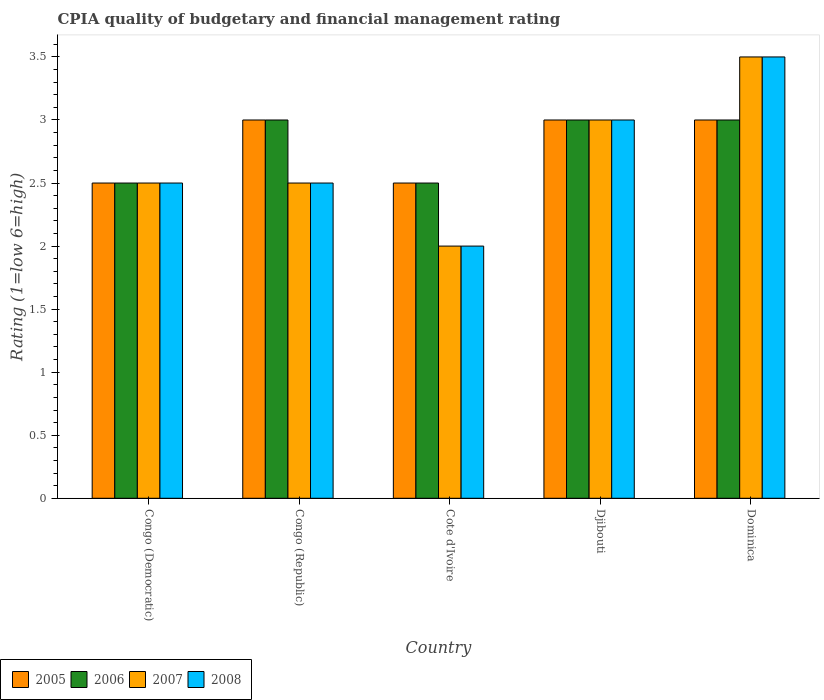How many different coloured bars are there?
Ensure brevity in your answer.  4. How many groups of bars are there?
Offer a terse response. 5. Are the number of bars per tick equal to the number of legend labels?
Give a very brief answer. Yes. What is the label of the 2nd group of bars from the left?
Your answer should be compact. Congo (Republic). Across all countries, what is the minimum CPIA rating in 2006?
Provide a succinct answer. 2.5. In which country was the CPIA rating in 2007 maximum?
Provide a short and direct response. Dominica. In which country was the CPIA rating in 2007 minimum?
Ensure brevity in your answer.  Cote d'Ivoire. What is the total CPIA rating in 2008 in the graph?
Offer a terse response. 13.5. What is the difference between the CPIA rating in 2005 in Congo (Democratic) and that in Djibouti?
Provide a short and direct response. -0.5. What is the difference between the CPIA rating in 2008 in Congo (Democratic) and the CPIA rating in 2006 in Djibouti?
Ensure brevity in your answer.  -0.5. In how many countries, is the CPIA rating in 2006 greater than 1.5?
Your answer should be compact. 5. What is the ratio of the CPIA rating in 2008 in Congo (Democratic) to that in Dominica?
Make the answer very short. 0.71. Is the CPIA rating in 2007 in Congo (Republic) less than that in Cote d'Ivoire?
Provide a succinct answer. No. What is the difference between the highest and the second highest CPIA rating in 2008?
Your answer should be compact. 0.5. Is the sum of the CPIA rating in 2006 in Congo (Republic) and Dominica greater than the maximum CPIA rating in 2005 across all countries?
Provide a succinct answer. Yes. Is it the case that in every country, the sum of the CPIA rating in 2005 and CPIA rating in 2008 is greater than the sum of CPIA rating in 2006 and CPIA rating in 2007?
Your answer should be very brief. No. What does the 1st bar from the left in Cote d'Ivoire represents?
Give a very brief answer. 2005. What does the 3rd bar from the right in Dominica represents?
Ensure brevity in your answer.  2006. Is it the case that in every country, the sum of the CPIA rating in 2006 and CPIA rating in 2007 is greater than the CPIA rating in 2005?
Offer a terse response. Yes. How many countries are there in the graph?
Give a very brief answer. 5. What is the difference between two consecutive major ticks on the Y-axis?
Keep it short and to the point. 0.5. Are the values on the major ticks of Y-axis written in scientific E-notation?
Keep it short and to the point. No. Where does the legend appear in the graph?
Ensure brevity in your answer.  Bottom left. How many legend labels are there?
Offer a very short reply. 4. What is the title of the graph?
Keep it short and to the point. CPIA quality of budgetary and financial management rating. What is the label or title of the Y-axis?
Ensure brevity in your answer.  Rating (1=low 6=high). What is the Rating (1=low 6=high) in 2007 in Congo (Democratic)?
Your answer should be very brief. 2.5. What is the Rating (1=low 6=high) in 2005 in Congo (Republic)?
Make the answer very short. 3. What is the Rating (1=low 6=high) in 2006 in Congo (Republic)?
Your answer should be compact. 3. What is the Rating (1=low 6=high) of 2006 in Cote d'Ivoire?
Offer a very short reply. 2.5. What is the Rating (1=low 6=high) in 2006 in Dominica?
Keep it short and to the point. 3. What is the Rating (1=low 6=high) in 2007 in Dominica?
Offer a very short reply. 3.5. Across all countries, what is the maximum Rating (1=low 6=high) in 2006?
Keep it short and to the point. 3. Across all countries, what is the maximum Rating (1=low 6=high) in 2008?
Your answer should be compact. 3.5. Across all countries, what is the minimum Rating (1=low 6=high) in 2005?
Offer a terse response. 2.5. Across all countries, what is the minimum Rating (1=low 6=high) in 2006?
Provide a succinct answer. 2.5. Across all countries, what is the minimum Rating (1=low 6=high) of 2007?
Your response must be concise. 2. Across all countries, what is the minimum Rating (1=low 6=high) of 2008?
Provide a succinct answer. 2. What is the total Rating (1=low 6=high) in 2005 in the graph?
Your response must be concise. 14. What is the total Rating (1=low 6=high) of 2007 in the graph?
Keep it short and to the point. 13.5. What is the difference between the Rating (1=low 6=high) in 2006 in Congo (Democratic) and that in Congo (Republic)?
Provide a short and direct response. -0.5. What is the difference between the Rating (1=low 6=high) of 2005 in Congo (Democratic) and that in Djibouti?
Offer a terse response. -0.5. What is the difference between the Rating (1=low 6=high) in 2006 in Congo (Democratic) and that in Djibouti?
Your response must be concise. -0.5. What is the difference between the Rating (1=low 6=high) in 2008 in Congo (Democratic) and that in Djibouti?
Make the answer very short. -0.5. What is the difference between the Rating (1=low 6=high) of 2005 in Congo (Democratic) and that in Dominica?
Provide a short and direct response. -0.5. What is the difference between the Rating (1=low 6=high) in 2008 in Congo (Democratic) and that in Dominica?
Your answer should be compact. -1. What is the difference between the Rating (1=low 6=high) of 2005 in Congo (Republic) and that in Cote d'Ivoire?
Your answer should be compact. 0.5. What is the difference between the Rating (1=low 6=high) in 2006 in Congo (Republic) and that in Cote d'Ivoire?
Offer a very short reply. 0.5. What is the difference between the Rating (1=low 6=high) of 2007 in Congo (Republic) and that in Cote d'Ivoire?
Provide a short and direct response. 0.5. What is the difference between the Rating (1=low 6=high) in 2008 in Congo (Republic) and that in Djibouti?
Make the answer very short. -0.5. What is the difference between the Rating (1=low 6=high) of 2005 in Congo (Republic) and that in Dominica?
Offer a terse response. 0. What is the difference between the Rating (1=low 6=high) in 2006 in Congo (Republic) and that in Dominica?
Your answer should be very brief. 0. What is the difference between the Rating (1=low 6=high) of 2007 in Cote d'Ivoire and that in Djibouti?
Provide a short and direct response. -1. What is the difference between the Rating (1=low 6=high) in 2006 in Cote d'Ivoire and that in Dominica?
Your answer should be compact. -0.5. What is the difference between the Rating (1=low 6=high) of 2007 in Cote d'Ivoire and that in Dominica?
Your answer should be compact. -1.5. What is the difference between the Rating (1=low 6=high) of 2008 in Cote d'Ivoire and that in Dominica?
Ensure brevity in your answer.  -1.5. What is the difference between the Rating (1=low 6=high) in 2006 in Djibouti and that in Dominica?
Offer a very short reply. 0. What is the difference between the Rating (1=low 6=high) of 2007 in Djibouti and that in Dominica?
Provide a succinct answer. -0.5. What is the difference between the Rating (1=low 6=high) in 2008 in Djibouti and that in Dominica?
Ensure brevity in your answer.  -0.5. What is the difference between the Rating (1=low 6=high) in 2005 in Congo (Democratic) and the Rating (1=low 6=high) in 2006 in Congo (Republic)?
Your response must be concise. -0.5. What is the difference between the Rating (1=low 6=high) of 2006 in Congo (Democratic) and the Rating (1=low 6=high) of 2007 in Congo (Republic)?
Provide a short and direct response. 0. What is the difference between the Rating (1=low 6=high) in 2006 in Congo (Democratic) and the Rating (1=low 6=high) in 2008 in Congo (Republic)?
Make the answer very short. 0. What is the difference between the Rating (1=low 6=high) of 2005 in Congo (Democratic) and the Rating (1=low 6=high) of 2006 in Cote d'Ivoire?
Ensure brevity in your answer.  0. What is the difference between the Rating (1=low 6=high) of 2005 in Congo (Democratic) and the Rating (1=low 6=high) of 2008 in Cote d'Ivoire?
Ensure brevity in your answer.  0.5. What is the difference between the Rating (1=low 6=high) of 2005 in Congo (Democratic) and the Rating (1=low 6=high) of 2007 in Djibouti?
Provide a succinct answer. -0.5. What is the difference between the Rating (1=low 6=high) of 2006 in Congo (Democratic) and the Rating (1=low 6=high) of 2007 in Djibouti?
Give a very brief answer. -0.5. What is the difference between the Rating (1=low 6=high) of 2006 in Congo (Democratic) and the Rating (1=low 6=high) of 2008 in Djibouti?
Your response must be concise. -0.5. What is the difference between the Rating (1=low 6=high) in 2005 in Congo (Democratic) and the Rating (1=low 6=high) in 2008 in Dominica?
Provide a short and direct response. -1. What is the difference between the Rating (1=low 6=high) of 2006 in Congo (Democratic) and the Rating (1=low 6=high) of 2007 in Dominica?
Offer a terse response. -1. What is the difference between the Rating (1=low 6=high) of 2006 in Congo (Democratic) and the Rating (1=low 6=high) of 2008 in Dominica?
Provide a short and direct response. -1. What is the difference between the Rating (1=low 6=high) in 2005 in Congo (Republic) and the Rating (1=low 6=high) in 2006 in Cote d'Ivoire?
Provide a succinct answer. 0.5. What is the difference between the Rating (1=low 6=high) in 2005 in Congo (Republic) and the Rating (1=low 6=high) in 2008 in Cote d'Ivoire?
Provide a short and direct response. 1. What is the difference between the Rating (1=low 6=high) in 2006 in Congo (Republic) and the Rating (1=low 6=high) in 2007 in Cote d'Ivoire?
Keep it short and to the point. 1. What is the difference between the Rating (1=low 6=high) of 2005 in Congo (Republic) and the Rating (1=low 6=high) of 2007 in Djibouti?
Your answer should be compact. 0. What is the difference between the Rating (1=low 6=high) of 2006 in Congo (Republic) and the Rating (1=low 6=high) of 2007 in Djibouti?
Offer a very short reply. 0. What is the difference between the Rating (1=low 6=high) in 2006 in Congo (Republic) and the Rating (1=low 6=high) in 2008 in Djibouti?
Ensure brevity in your answer.  0. What is the difference between the Rating (1=low 6=high) of 2005 in Congo (Republic) and the Rating (1=low 6=high) of 2006 in Dominica?
Offer a very short reply. 0. What is the difference between the Rating (1=low 6=high) in 2005 in Congo (Republic) and the Rating (1=low 6=high) in 2007 in Dominica?
Keep it short and to the point. -0.5. What is the difference between the Rating (1=low 6=high) in 2006 in Congo (Republic) and the Rating (1=low 6=high) in 2008 in Dominica?
Provide a succinct answer. -0.5. What is the difference between the Rating (1=low 6=high) of 2007 in Congo (Republic) and the Rating (1=low 6=high) of 2008 in Dominica?
Provide a succinct answer. -1. What is the difference between the Rating (1=low 6=high) in 2005 in Cote d'Ivoire and the Rating (1=low 6=high) in 2006 in Djibouti?
Your answer should be compact. -0.5. What is the difference between the Rating (1=low 6=high) in 2006 in Cote d'Ivoire and the Rating (1=low 6=high) in 2007 in Djibouti?
Provide a succinct answer. -0.5. What is the difference between the Rating (1=low 6=high) of 2006 in Cote d'Ivoire and the Rating (1=low 6=high) of 2008 in Djibouti?
Provide a short and direct response. -0.5. What is the difference between the Rating (1=low 6=high) in 2007 in Cote d'Ivoire and the Rating (1=low 6=high) in 2008 in Dominica?
Provide a succinct answer. -1.5. What is the difference between the Rating (1=low 6=high) in 2005 in Djibouti and the Rating (1=low 6=high) in 2006 in Dominica?
Keep it short and to the point. 0. What is the difference between the Rating (1=low 6=high) in 2005 in Djibouti and the Rating (1=low 6=high) in 2008 in Dominica?
Provide a short and direct response. -0.5. What is the average Rating (1=low 6=high) of 2005 per country?
Offer a terse response. 2.8. What is the average Rating (1=low 6=high) in 2007 per country?
Provide a succinct answer. 2.7. What is the difference between the Rating (1=low 6=high) in 2005 and Rating (1=low 6=high) in 2006 in Congo (Democratic)?
Offer a very short reply. 0. What is the difference between the Rating (1=low 6=high) of 2005 and Rating (1=low 6=high) of 2007 in Congo (Democratic)?
Your answer should be compact. 0. What is the difference between the Rating (1=low 6=high) of 2006 and Rating (1=low 6=high) of 2008 in Congo (Democratic)?
Offer a terse response. 0. What is the difference between the Rating (1=low 6=high) of 2007 and Rating (1=low 6=high) of 2008 in Congo (Democratic)?
Your answer should be compact. 0. What is the difference between the Rating (1=low 6=high) of 2005 and Rating (1=low 6=high) of 2006 in Congo (Republic)?
Make the answer very short. 0. What is the difference between the Rating (1=low 6=high) of 2005 and Rating (1=low 6=high) of 2008 in Congo (Republic)?
Offer a very short reply. 0.5. What is the difference between the Rating (1=low 6=high) of 2006 and Rating (1=low 6=high) of 2008 in Congo (Republic)?
Make the answer very short. 0.5. What is the difference between the Rating (1=low 6=high) of 2007 and Rating (1=low 6=high) of 2008 in Congo (Republic)?
Give a very brief answer. 0. What is the difference between the Rating (1=low 6=high) in 2005 and Rating (1=low 6=high) in 2006 in Cote d'Ivoire?
Your response must be concise. 0. What is the difference between the Rating (1=low 6=high) of 2005 and Rating (1=low 6=high) of 2007 in Cote d'Ivoire?
Provide a succinct answer. 0.5. What is the difference between the Rating (1=low 6=high) in 2005 and Rating (1=low 6=high) in 2008 in Cote d'Ivoire?
Make the answer very short. 0.5. What is the difference between the Rating (1=low 6=high) of 2006 and Rating (1=low 6=high) of 2007 in Cote d'Ivoire?
Offer a very short reply. 0.5. What is the difference between the Rating (1=low 6=high) in 2005 and Rating (1=low 6=high) in 2007 in Djibouti?
Offer a very short reply. 0. What is the difference between the Rating (1=low 6=high) of 2006 and Rating (1=low 6=high) of 2008 in Djibouti?
Keep it short and to the point. 0. What is the difference between the Rating (1=low 6=high) in 2007 and Rating (1=low 6=high) in 2008 in Djibouti?
Your answer should be very brief. 0. What is the difference between the Rating (1=low 6=high) of 2005 and Rating (1=low 6=high) of 2008 in Dominica?
Your response must be concise. -0.5. What is the difference between the Rating (1=low 6=high) in 2006 and Rating (1=low 6=high) in 2008 in Dominica?
Provide a short and direct response. -0.5. What is the difference between the Rating (1=low 6=high) in 2007 and Rating (1=low 6=high) in 2008 in Dominica?
Give a very brief answer. 0. What is the ratio of the Rating (1=low 6=high) of 2005 in Congo (Democratic) to that in Djibouti?
Provide a short and direct response. 0.83. What is the ratio of the Rating (1=low 6=high) in 2008 in Congo (Democratic) to that in Djibouti?
Your response must be concise. 0.83. What is the ratio of the Rating (1=low 6=high) in 2005 in Congo (Democratic) to that in Dominica?
Offer a very short reply. 0.83. What is the ratio of the Rating (1=low 6=high) of 2006 in Congo (Democratic) to that in Dominica?
Offer a very short reply. 0.83. What is the ratio of the Rating (1=low 6=high) of 2005 in Congo (Republic) to that in Cote d'Ivoire?
Keep it short and to the point. 1.2. What is the ratio of the Rating (1=low 6=high) in 2006 in Congo (Republic) to that in Cote d'Ivoire?
Your answer should be very brief. 1.2. What is the ratio of the Rating (1=low 6=high) in 2007 in Congo (Republic) to that in Cote d'Ivoire?
Your response must be concise. 1.25. What is the ratio of the Rating (1=low 6=high) of 2008 in Congo (Republic) to that in Cote d'Ivoire?
Provide a short and direct response. 1.25. What is the ratio of the Rating (1=low 6=high) of 2005 in Congo (Republic) to that in Djibouti?
Provide a short and direct response. 1. What is the ratio of the Rating (1=low 6=high) of 2008 in Congo (Republic) to that in Djibouti?
Make the answer very short. 0.83. What is the ratio of the Rating (1=low 6=high) of 2006 in Congo (Republic) to that in Dominica?
Give a very brief answer. 1. What is the ratio of the Rating (1=low 6=high) of 2007 in Cote d'Ivoire to that in Djibouti?
Your response must be concise. 0.67. What is the ratio of the Rating (1=low 6=high) in 2008 in Cote d'Ivoire to that in Djibouti?
Ensure brevity in your answer.  0.67. What is the ratio of the Rating (1=low 6=high) in 2005 in Cote d'Ivoire to that in Dominica?
Ensure brevity in your answer.  0.83. What is the ratio of the Rating (1=low 6=high) of 2007 in Cote d'Ivoire to that in Dominica?
Your answer should be compact. 0.57. What is the ratio of the Rating (1=low 6=high) in 2008 in Cote d'Ivoire to that in Dominica?
Offer a very short reply. 0.57. What is the ratio of the Rating (1=low 6=high) in 2007 in Djibouti to that in Dominica?
Offer a terse response. 0.86. What is the ratio of the Rating (1=low 6=high) in 2008 in Djibouti to that in Dominica?
Provide a succinct answer. 0.86. What is the difference between the highest and the second highest Rating (1=low 6=high) in 2005?
Provide a short and direct response. 0. What is the difference between the highest and the second highest Rating (1=low 6=high) in 2007?
Your response must be concise. 0.5. What is the difference between the highest and the lowest Rating (1=low 6=high) of 2005?
Your answer should be compact. 0.5. What is the difference between the highest and the lowest Rating (1=low 6=high) of 2006?
Keep it short and to the point. 0.5. What is the difference between the highest and the lowest Rating (1=low 6=high) in 2007?
Provide a succinct answer. 1.5. What is the difference between the highest and the lowest Rating (1=low 6=high) of 2008?
Provide a succinct answer. 1.5. 